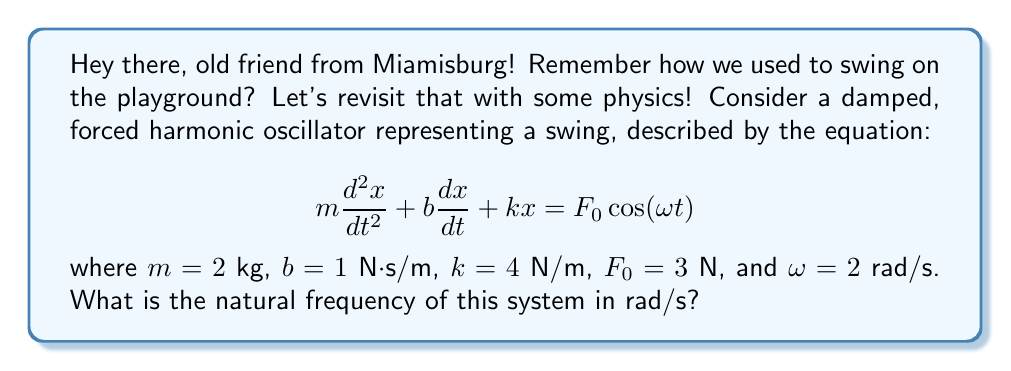What is the answer to this math problem? Let's approach this step-by-step:

1) The natural frequency of a harmonic oscillator is the frequency at which the system would oscillate in the absence of damping or external forcing.

2) For a simple harmonic oscillator, the natural frequency $\omega_n$ is given by:

   $$\omega_n = \sqrt{\frac{k}{m}}$$

3) In our case:
   - $k = 4$ N/m (spring constant)
   - $m = 2$ kg (mass)

4) Let's substitute these values into the equation:

   $$\omega_n = \sqrt{\frac{4}{2}}$$

5) Simplify:

   $$\omega_n = \sqrt{2}$$

6) This gives us the natural frequency in radians per second (rad/s).

Note: The damping coefficient $b$ and the forcing term ($F_0$ and $\omega$) do not affect the natural frequency of the system. They would, however, affect the system's overall behavior and its response to the external force.
Answer: $\sqrt{2}$ rad/s 